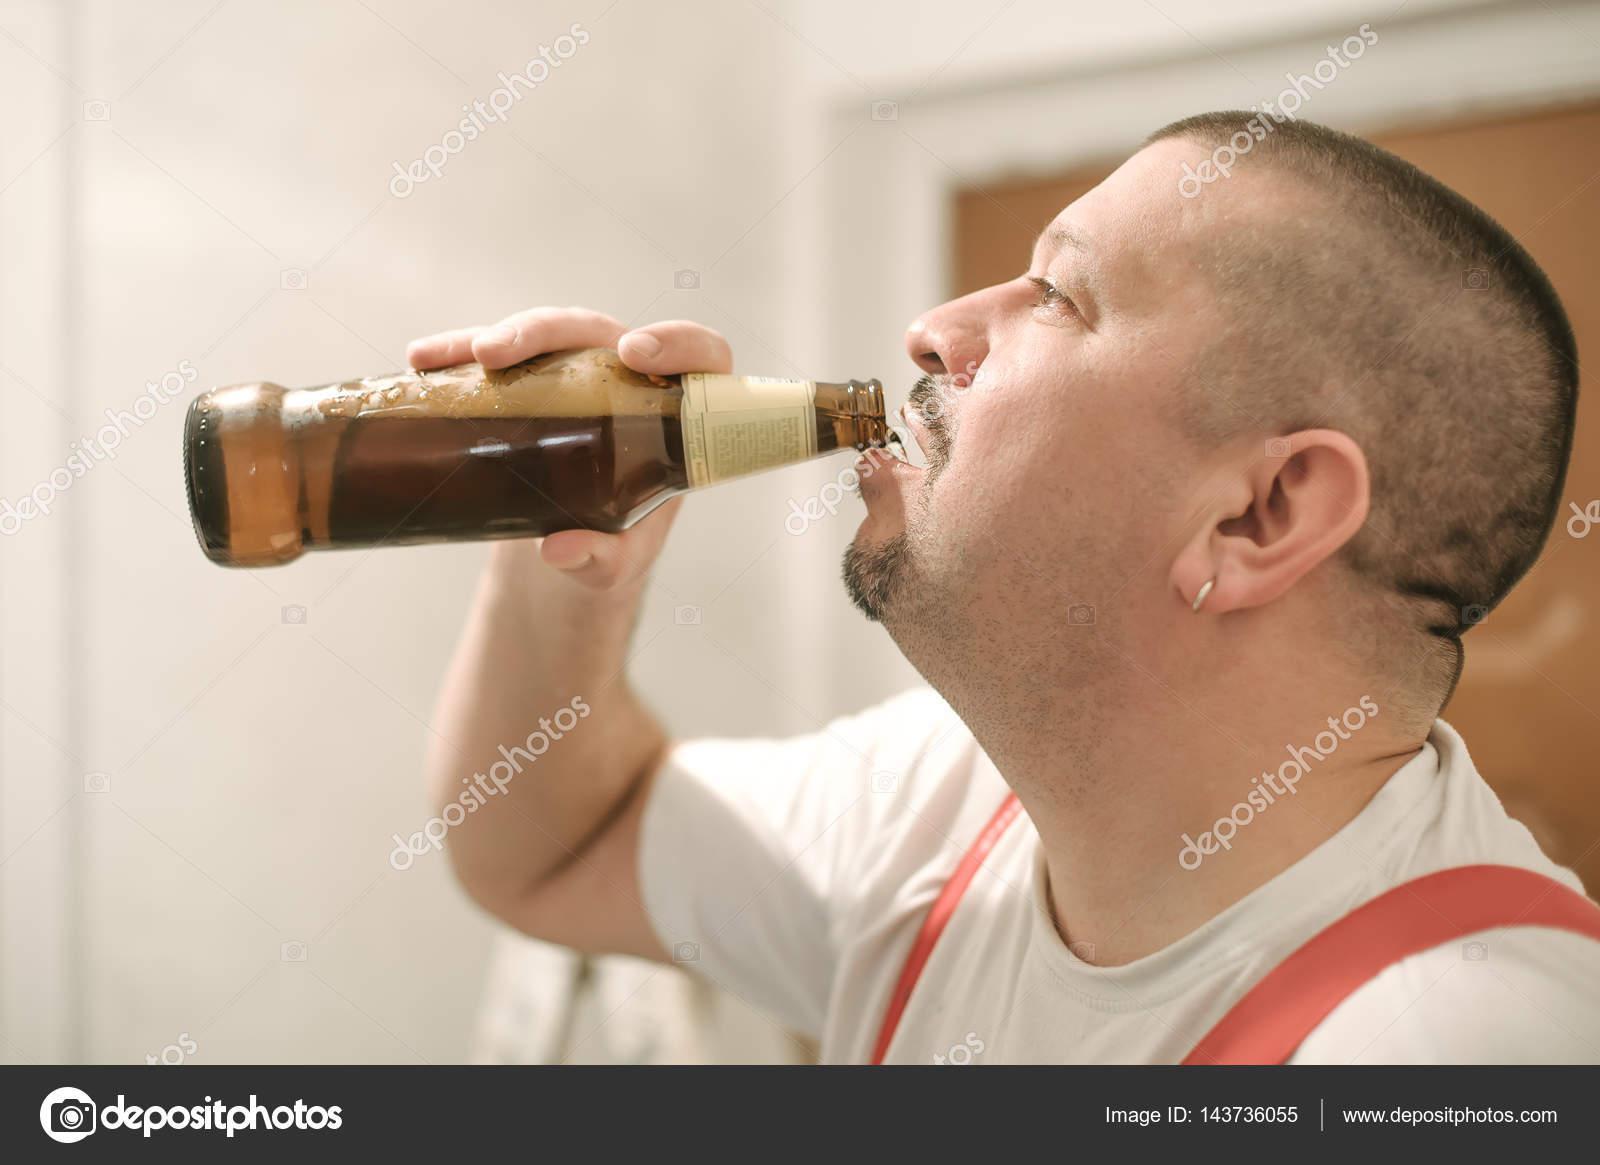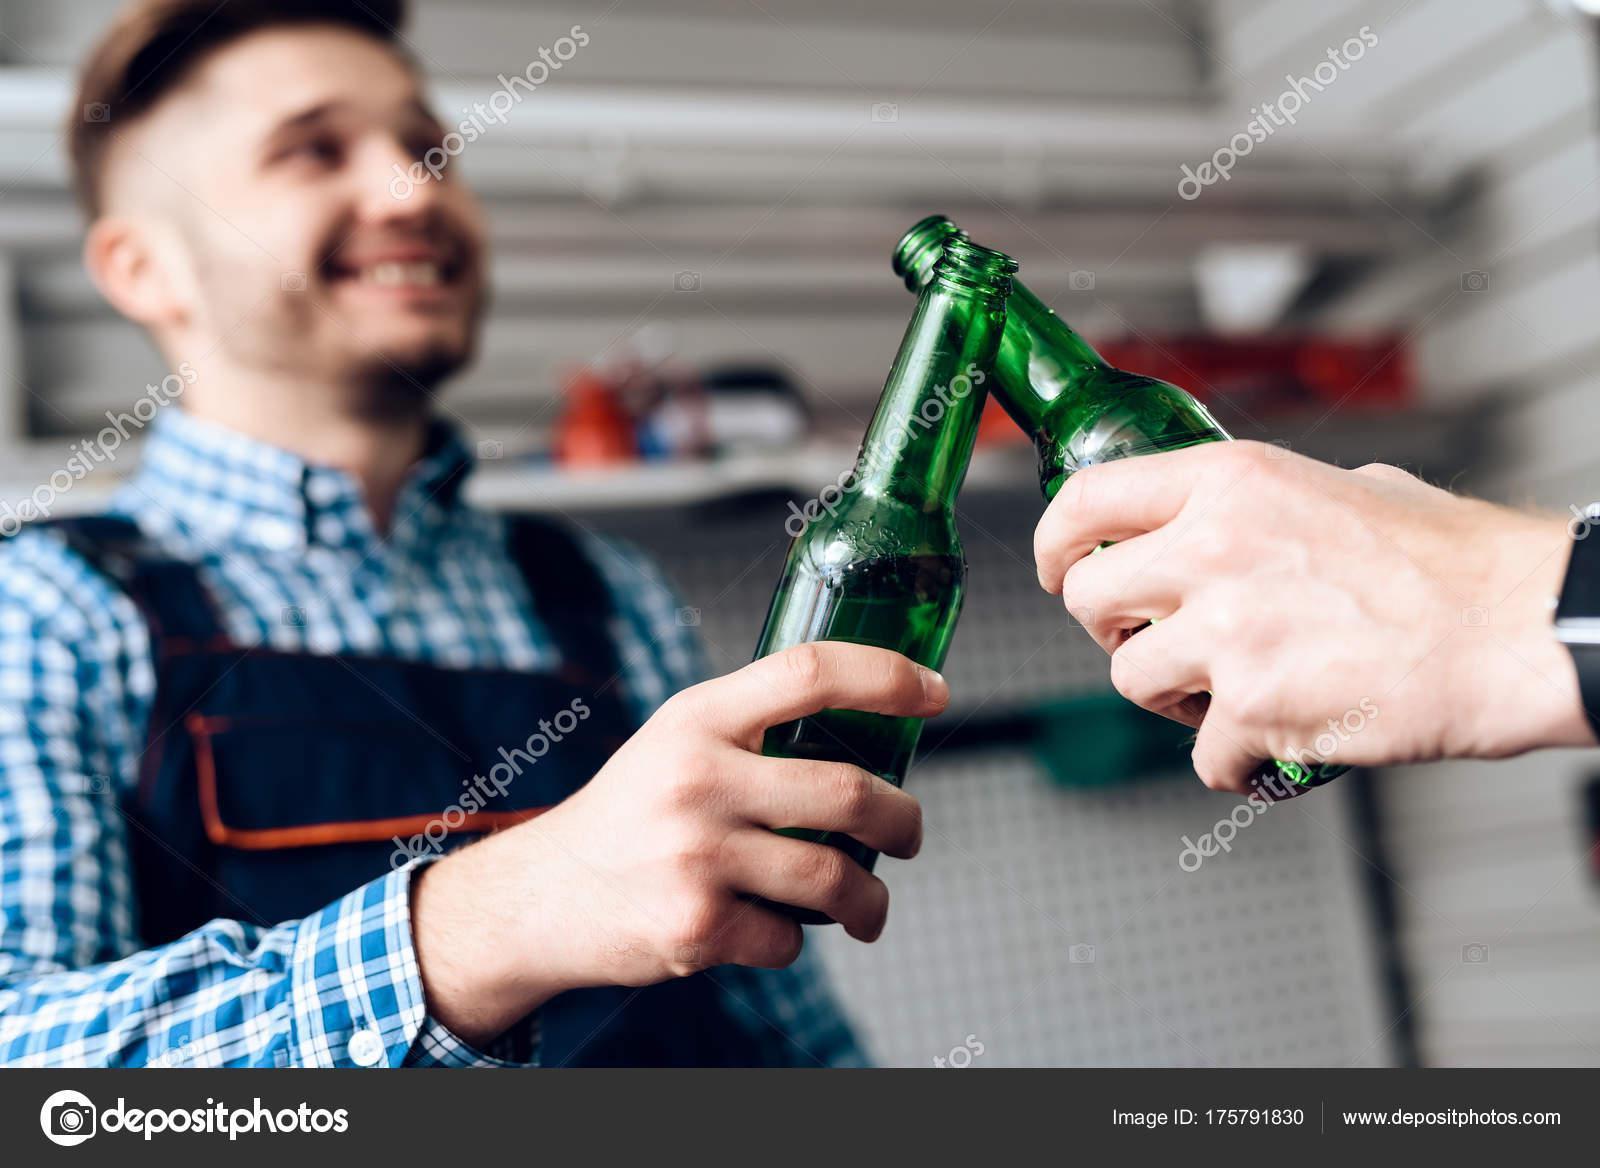The first image is the image on the left, the second image is the image on the right. Evaluate the accuracy of this statement regarding the images: "Three hands are touching three bottles.". Is it true? Answer yes or no. Yes. The first image is the image on the left, the second image is the image on the right. Analyze the images presented: Is the assertion "An adult is drinking a beer with the bottle touching their mouth." valid? Answer yes or no. Yes. 